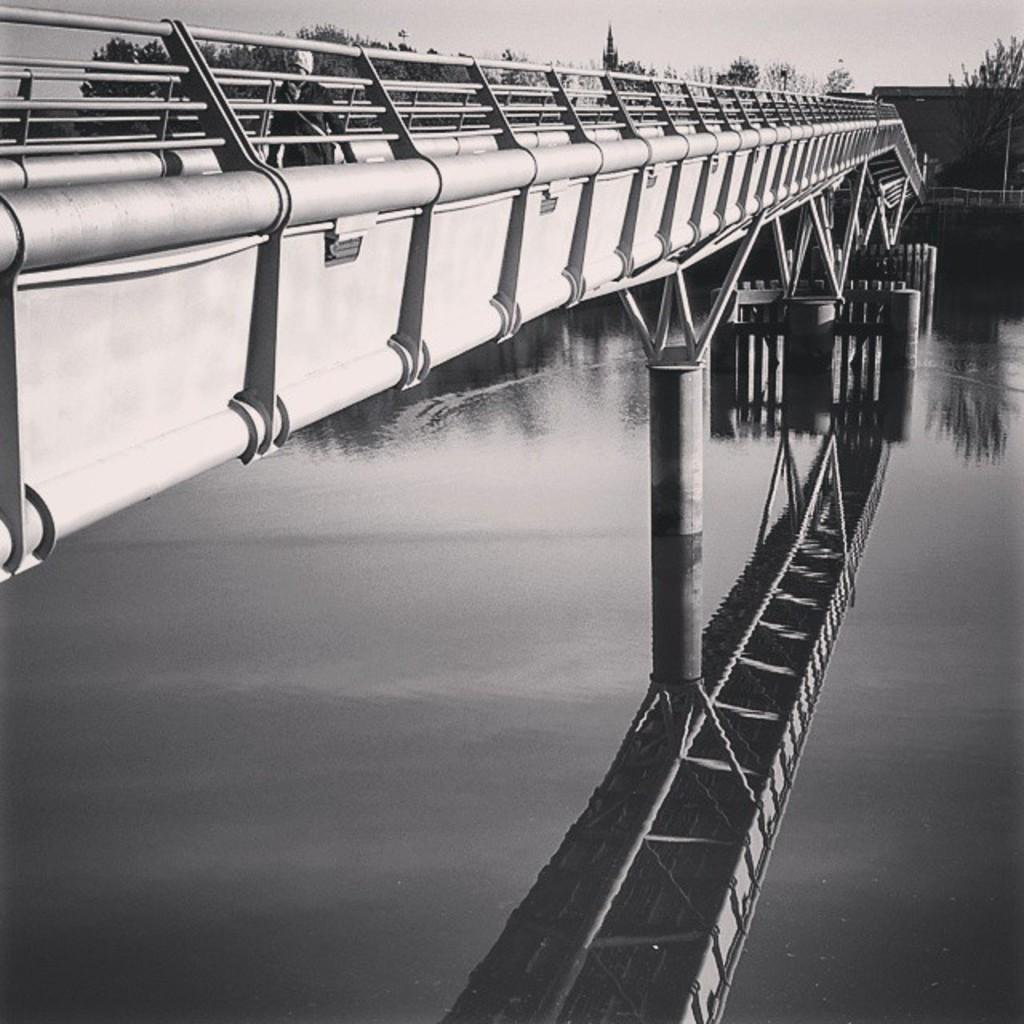What structure can be seen in the image? There is a bridge in the image. What is the human in the image doing? A human is walking in the image. What type of vegetation is present in the image? There are trees in the image. What type of building can be seen in the image? There is a house in the image. What natural element is visible in the image? Water is visible in the image. What hobbies do the geese in the image enjoy? There are no geese present in the image, so we cannot determine their hobbies. What level of difficulty is the bridge in the image designed for? The image does not provide information about the level of difficulty of the bridge, so we cannot determine this. 